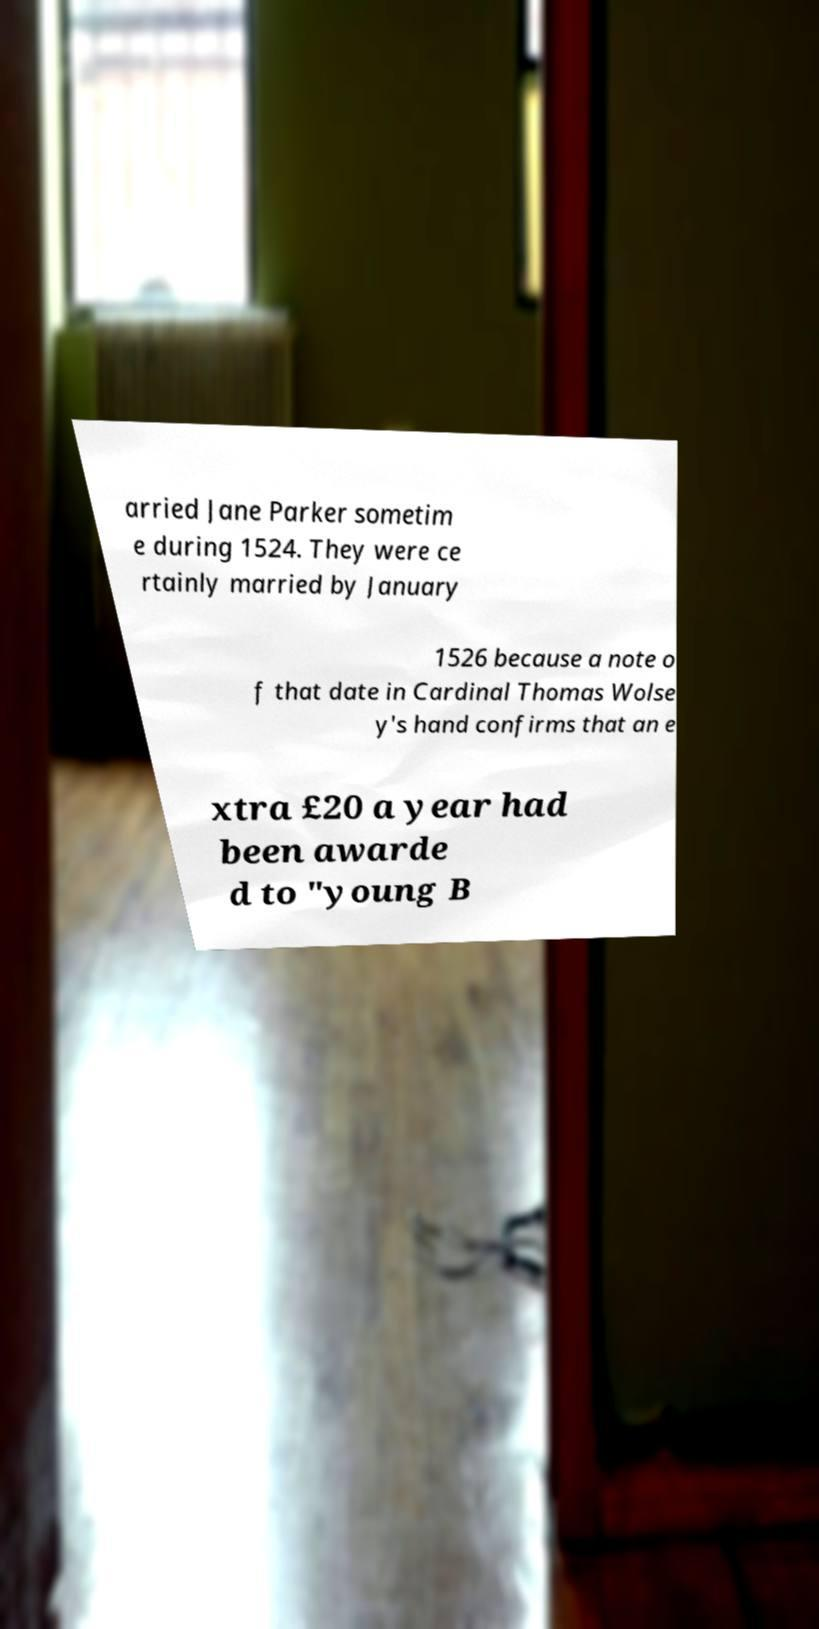What messages or text are displayed in this image? I need them in a readable, typed format. arried Jane Parker sometim e during 1524. They were ce rtainly married by January 1526 because a note o f that date in Cardinal Thomas Wolse y's hand confirms that an e xtra £20 a year had been awarde d to "young B 